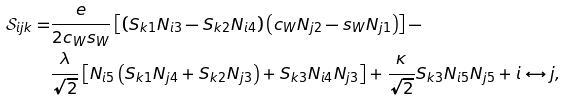<formula> <loc_0><loc_0><loc_500><loc_500>\mathcal { S } _ { i j k } = & \frac { e } { 2 c _ { W } s _ { W } } \left [ \left ( S _ { k 1 } N _ { i 3 } - S _ { k 2 } N _ { i 4 } \right ) \left ( c _ { W } N _ { j 2 } - s _ { W } N _ { j 1 } \right ) \right ] - \\ & \frac { \lambda } { \sqrt { 2 } } \left [ N _ { i 5 } \left ( S _ { k 1 } N _ { j 4 } + S _ { k 2 } N _ { j 3 } \right ) + S _ { k 3 } N _ { i 4 } N _ { j 3 } \right ] + \frac { \kappa } { \sqrt { 2 } } S _ { k 3 } N _ { i 5 } N _ { j 5 } + i \leftrightarrow j ,</formula> 